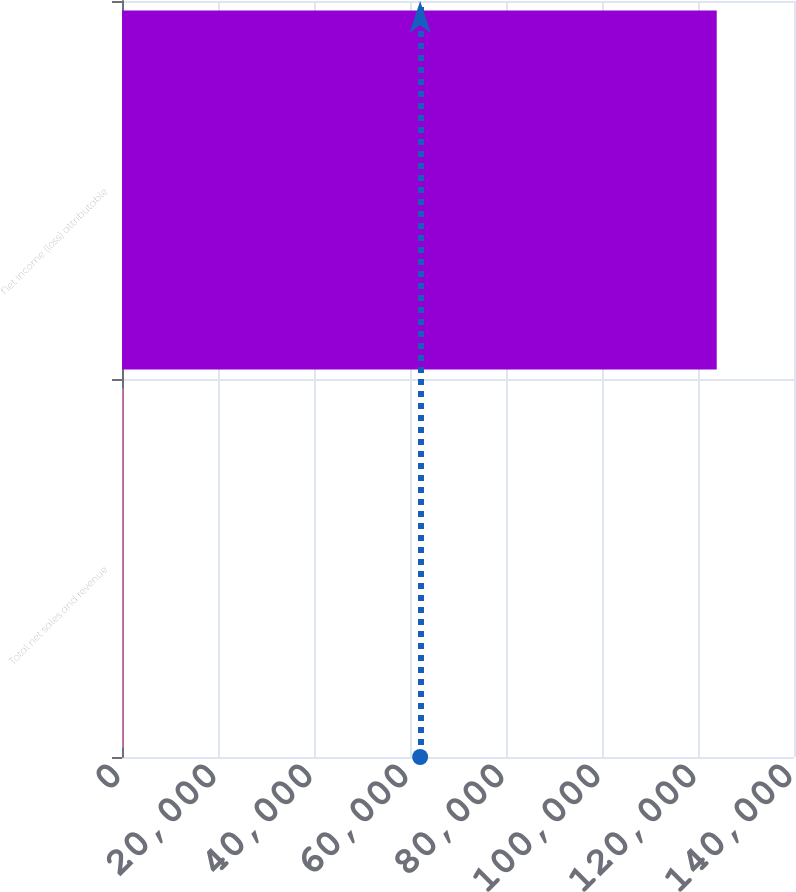<chart> <loc_0><loc_0><loc_500><loc_500><bar_chart><fcel>Total net sales and revenue<fcel>Net income (loss) attributable<nl><fcel>327<fcel>123902<nl></chart> 